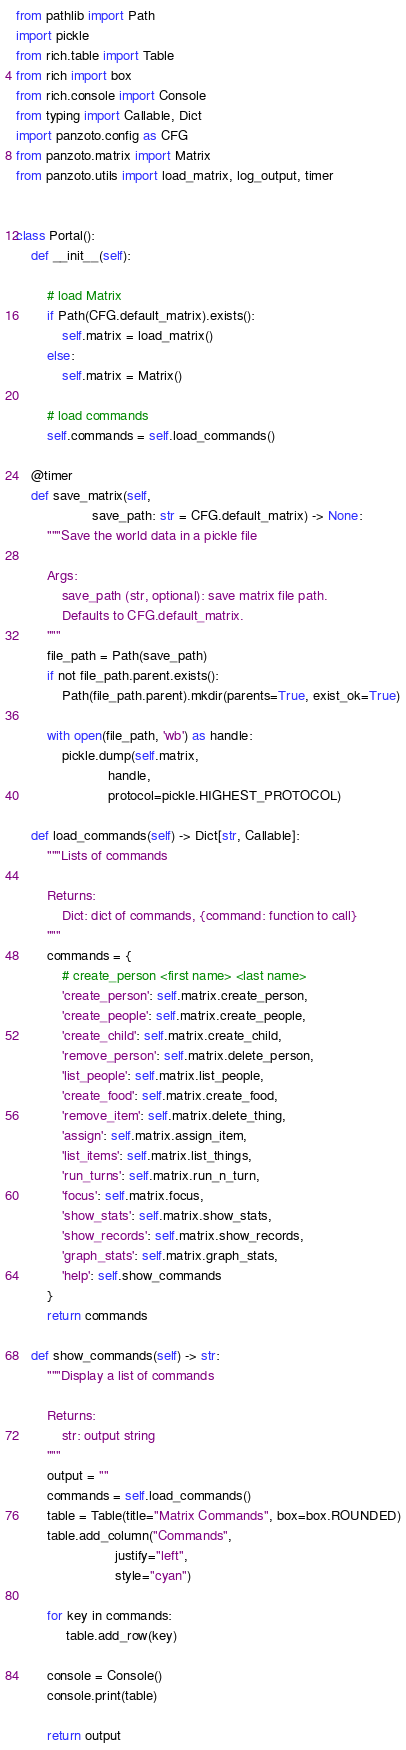<code> <loc_0><loc_0><loc_500><loc_500><_Python_>from pathlib import Path
import pickle
from rich.table import Table
from rich import box
from rich.console import Console
from typing import Callable, Dict
import panzoto.config as CFG
from panzoto.matrix import Matrix
from panzoto.utils import load_matrix, log_output, timer


class Portal():
    def __init__(self):

        # load Matrix
        if Path(CFG.default_matrix).exists():
            self.matrix = load_matrix()
        else:
            self.matrix = Matrix()

        # load commands
        self.commands = self.load_commands()

    @timer
    def save_matrix(self,
                    save_path: str = CFG.default_matrix) -> None:
        """Save the world data in a pickle file

        Args:
            save_path (str, optional): save matrix file path. 
            Defaults to CFG.default_matrix.
        """
        file_path = Path(save_path)
        if not file_path.parent.exists():
            Path(file_path.parent).mkdir(parents=True, exist_ok=True)

        with open(file_path, 'wb') as handle:
            pickle.dump(self.matrix,
                        handle,
                        protocol=pickle.HIGHEST_PROTOCOL)

    def load_commands(self) -> Dict[str, Callable]:
        """Lists of commands 

        Returns:
            Dict: dict of commands, {command: function to call}
        """
        commands = {
            # create_person <first name> <last name>
            'create_person': self.matrix.create_person,
            'create_people': self.matrix.create_people,
            'create_child': self.matrix.create_child,
            'remove_person': self.matrix.delete_person,
            'list_people': self.matrix.list_people,
            'create_food': self.matrix.create_food,
            'remove_item': self.matrix.delete_thing,
            'assign': self.matrix.assign_item,
            'list_items': self.matrix.list_things,
            'run_turns': self.matrix.run_n_turn,
            'focus': self.matrix.focus,
            'show_stats': self.matrix.show_stats,
            'show_records': self.matrix.show_records,
            'graph_stats': self.matrix.graph_stats,
            'help': self.show_commands
        }
        return commands

    def show_commands(self) -> str:
        """Display a list of commands

        Returns:
            str: output string
        """
        output = ""
        commands = self.load_commands()
        table = Table(title="Matrix Commands", box=box.ROUNDED)
        table.add_column("Commands", 
                          justify="left", 
                          style="cyan")

        for key in commands:
             table.add_row(key)

        console = Console()
        console.print(table)

        return output
</code> 